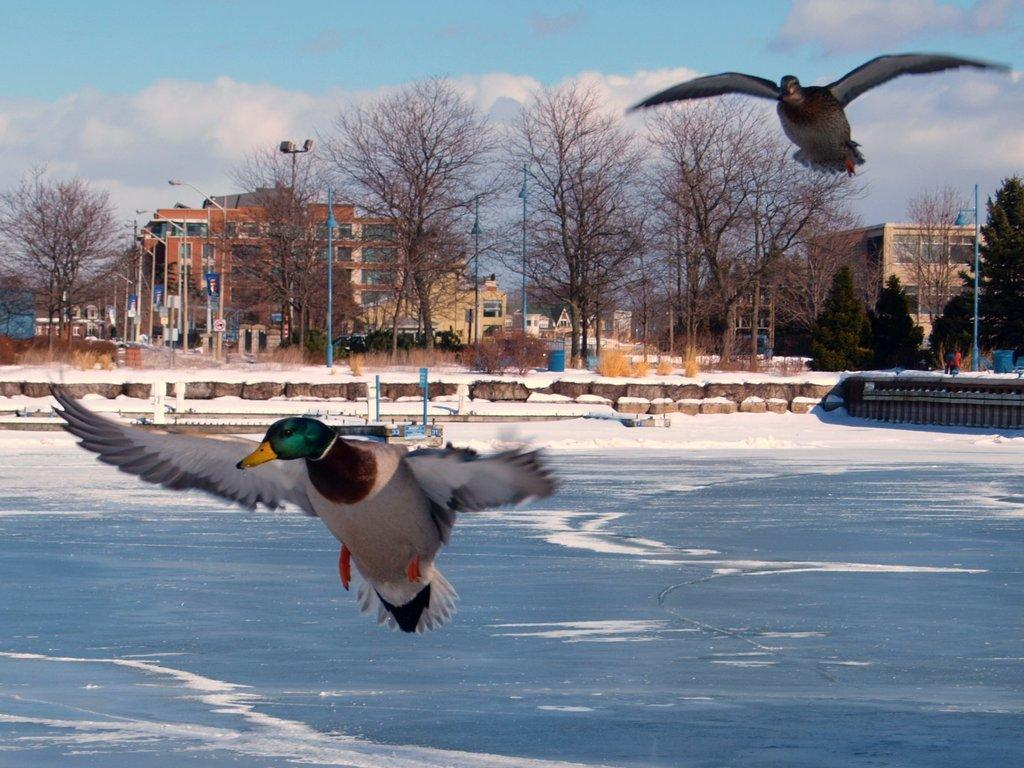What animals can be seen in the image? There are two birds flying in the air. What natural element is visible in the image? Water is visible in the image. What structures can be seen in the image? There are poles, boards, trees, and buildings in the image. What is the weather like in the image? There is snow visible in the image, and there are clouds in the sky. What type of mark can be seen on the snakes in the image? There are no snakes present in the image, so there is no mark to be seen. How does the anger of the clouds affect the image? The clouds in the image do not display any emotions, such as anger, as they are natural phenomena and not living beings. 